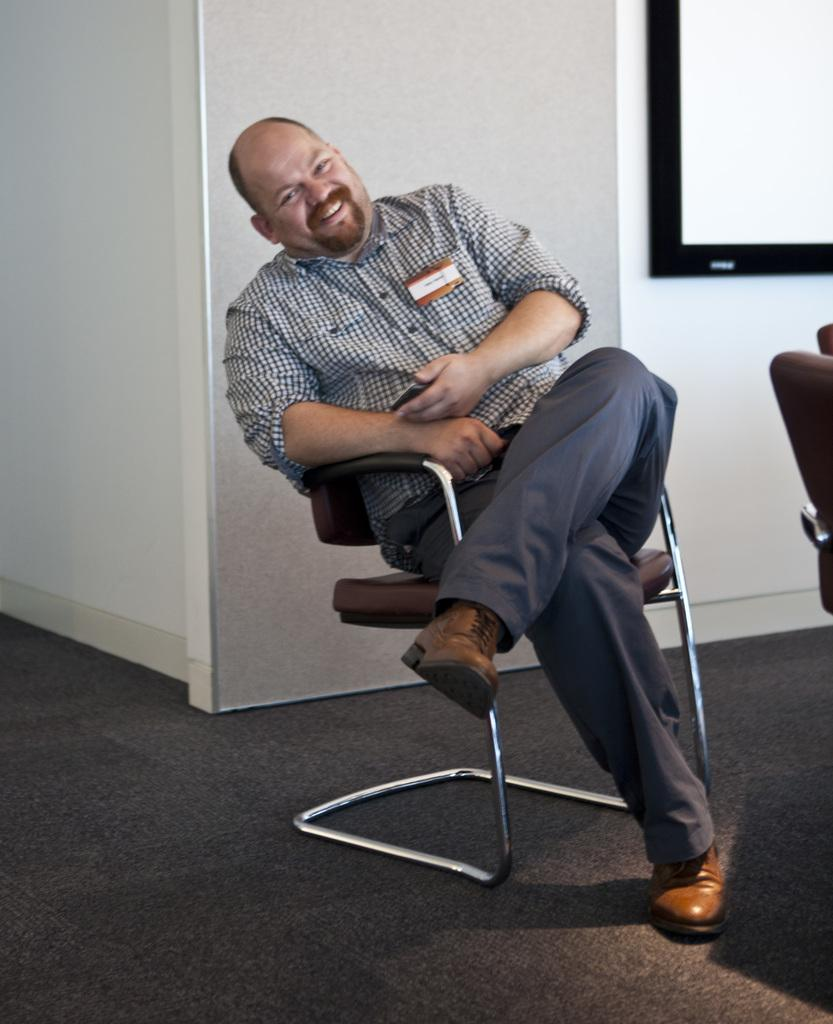What is the main subject of the image? There is a person in the image. What is the person doing in the image? The person is sitting on a chair. What type of thumb can be seen on the person's hand in the image? There is no thumb visible in the image, as the person's hands are not shown. What is the person doing with the pear in the image? There is no pear present in the image, so it cannot be determined what the person might be doing with it. 